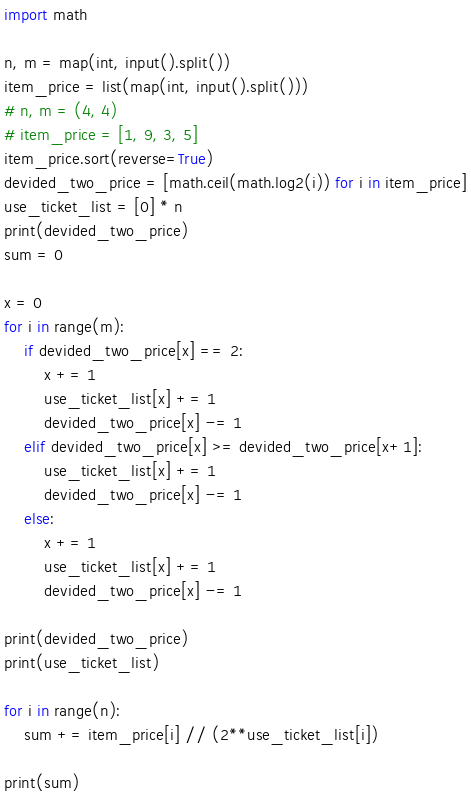<code> <loc_0><loc_0><loc_500><loc_500><_Python_>import math

n, m = map(int, input().split())
item_price = list(map(int, input().split()))
# n, m = (4, 4)
# item_price = [1, 9, 3, 5]
item_price.sort(reverse=True)
devided_two_price = [math.ceil(math.log2(i)) for i in item_price]
use_ticket_list = [0] * n
print(devided_two_price)
sum = 0

x = 0
for i in range(m):
    if devided_two_price[x] == 2:
        x += 1
        use_ticket_list[x] += 1
        devided_two_price[x] -= 1
    elif devided_two_price[x] >= devided_two_price[x+1]:
        use_ticket_list[x] += 1
        devided_two_price[x] -= 1
    else:
        x += 1
        use_ticket_list[x] += 1
        devided_two_price[x] -= 1

print(devided_two_price)
print(use_ticket_list)

for i in range(n):
    sum += item_price[i] // (2**use_ticket_list[i])

print(sum)</code> 